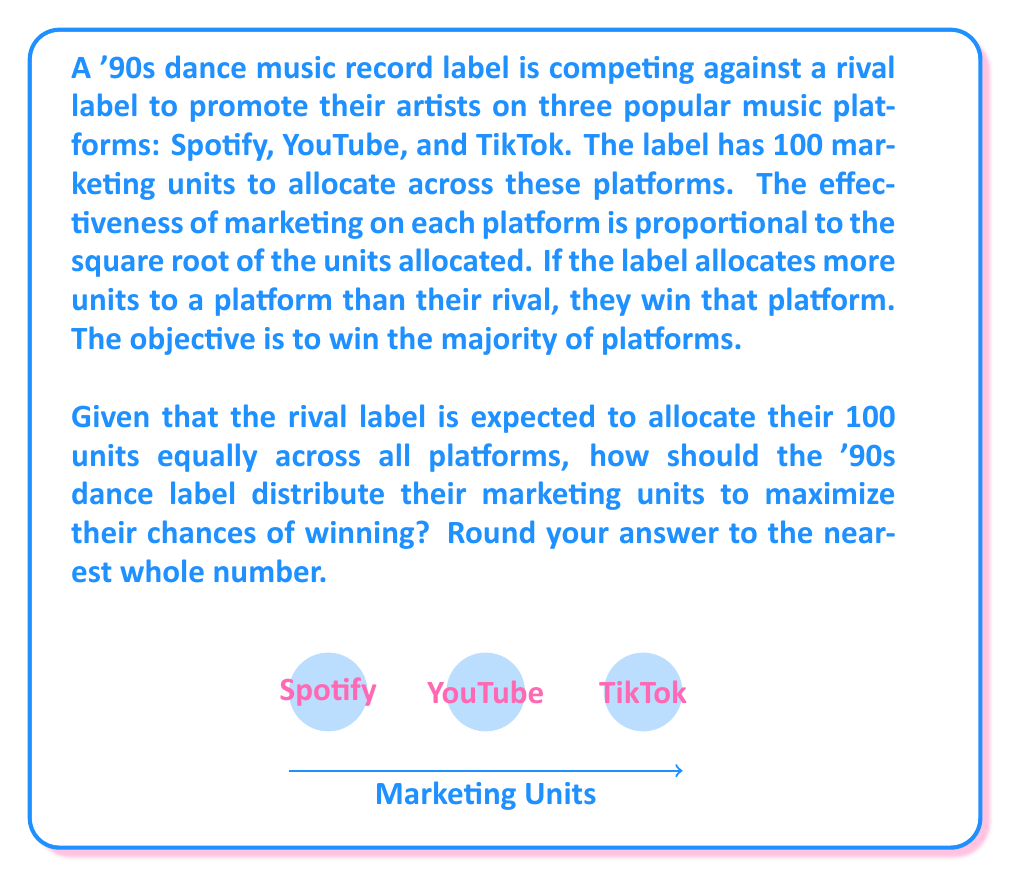What is the answer to this math problem? Let's approach this step-by-step:

1) First, we need to understand the Colonel Blotto game scenario. In this case, we need to allocate resources (marketing units) across three platforms to win the majority (at least 2 out of 3).

2) The rival label is allocating 100 units equally, so they're putting $\frac{100}{3} \approx 33.33$ units on each platform.

3) To win a platform, we need to allocate more than 33.33 units, and the effectiveness is proportional to the square root of the units allocated.

4) Let's denote our allocations as $x$, $y$, and $z$ for Spotify, YouTube, and TikTok respectively. We need to solve:

   $$\max(\sqrt{x}, \sqrt{y}, \sqrt{z})$$
   subject to $x + y + z = 100$ and $x > 33.33$, $y > 33.33$

5) Given the square root relationship, the optimal strategy is to allocate resources equally to the two platforms we want to win, and nothing to the third.

6) So, we need to solve:
   $$x = y = \frac{100}{2} = 50$$

7) This allocation ensures we win two platforms (Spotify and YouTube in this case) while leaving TikTok to the rival.

8) We can verify:
   $\sqrt{50} \approx 7.07 > \sqrt{33.33} \approx 5.77$

So our allocation of 50 units each to Spotify and YouTube will be more effective than the rival's 33.33 units.
Answer: (50, 50, 0) 